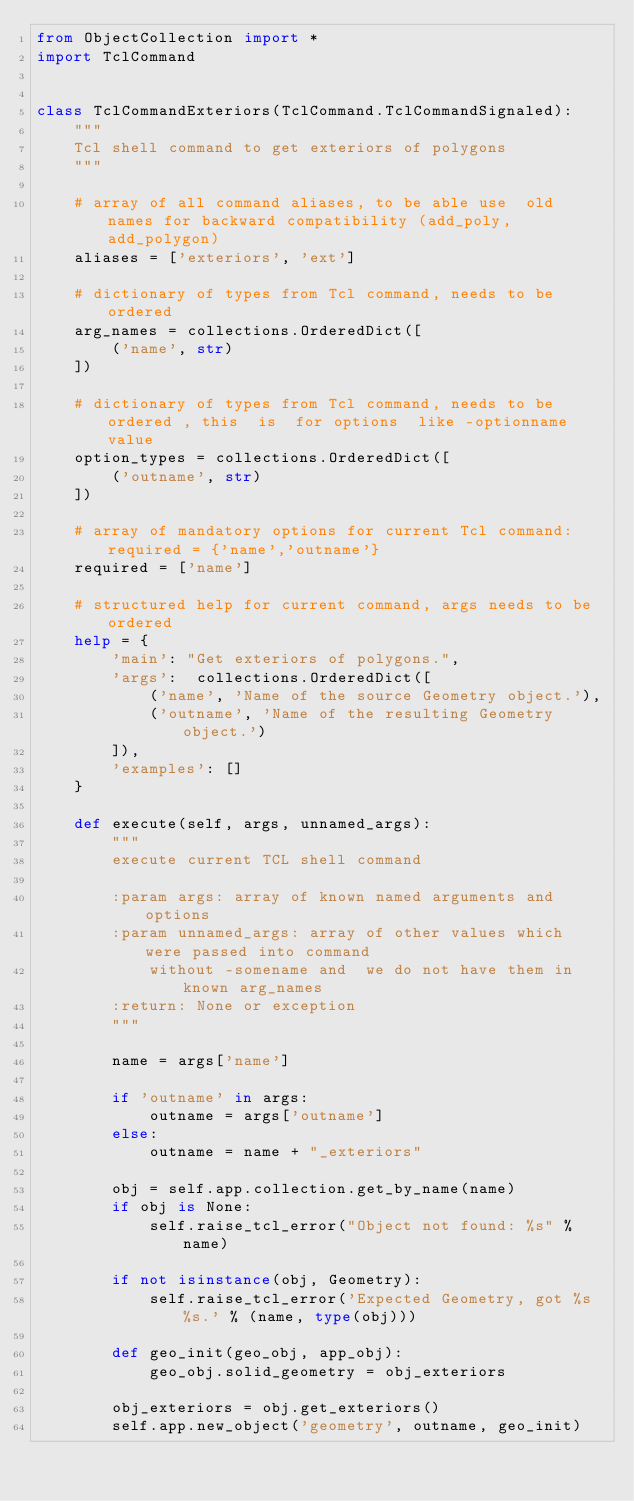Convert code to text. <code><loc_0><loc_0><loc_500><loc_500><_Python_>from ObjectCollection import *
import TclCommand


class TclCommandExteriors(TclCommand.TclCommandSignaled):
    """
    Tcl shell command to get exteriors of polygons
    """

    # array of all command aliases, to be able use  old names for backward compatibility (add_poly, add_polygon)
    aliases = ['exteriors', 'ext']

    # dictionary of types from Tcl command, needs to be ordered
    arg_names = collections.OrderedDict([
        ('name', str)
    ])

    # dictionary of types from Tcl command, needs to be ordered , this  is  for options  like -optionname value
    option_types = collections.OrderedDict([
        ('outname', str)
    ])

    # array of mandatory options for current Tcl command: required = {'name','outname'}
    required = ['name']

    # structured help for current command, args needs to be ordered
    help = {
        'main': "Get exteriors of polygons.",
        'args':  collections.OrderedDict([
            ('name', 'Name of the source Geometry object.'),
            ('outname', 'Name of the resulting Geometry object.')
        ]),
        'examples': []
    }

    def execute(self, args, unnamed_args):
        """
        execute current TCL shell command

        :param args: array of known named arguments and options
        :param unnamed_args: array of other values which were passed into command
            without -somename and  we do not have them in known arg_names
        :return: None or exception
        """

        name = args['name']

        if 'outname' in args:
            outname = args['outname']
        else:
            outname = name + "_exteriors"

        obj = self.app.collection.get_by_name(name)
        if obj is None:
            self.raise_tcl_error("Object not found: %s" % name)

        if not isinstance(obj, Geometry):
            self.raise_tcl_error('Expected Geometry, got %s %s.' % (name, type(obj)))

        def geo_init(geo_obj, app_obj):
            geo_obj.solid_geometry = obj_exteriors

        obj_exteriors = obj.get_exteriors()
        self.app.new_object('geometry', outname, geo_init)
</code> 